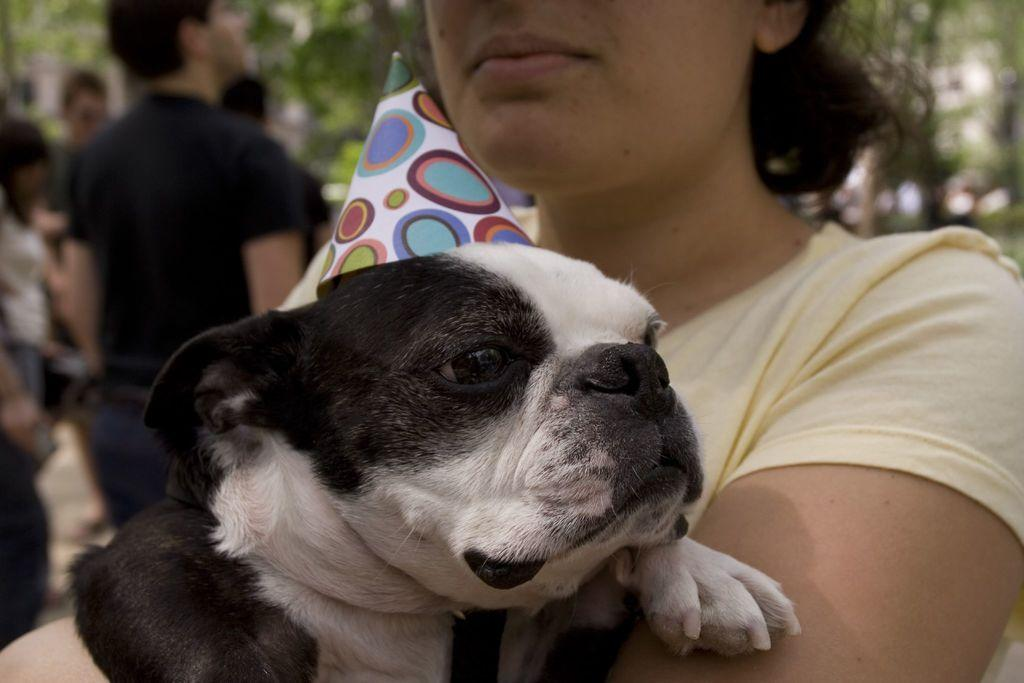Who is the main subject in the image? There is a woman in the image. What is the woman holding in the image? The woman is holding a dog. Can you describe the people in the background of the image? There are people standing in the background of the image, and they are on the left side. What type of paste is being used by the dog in the image? There is no paste present in the image, and the dog is not using any paste. 